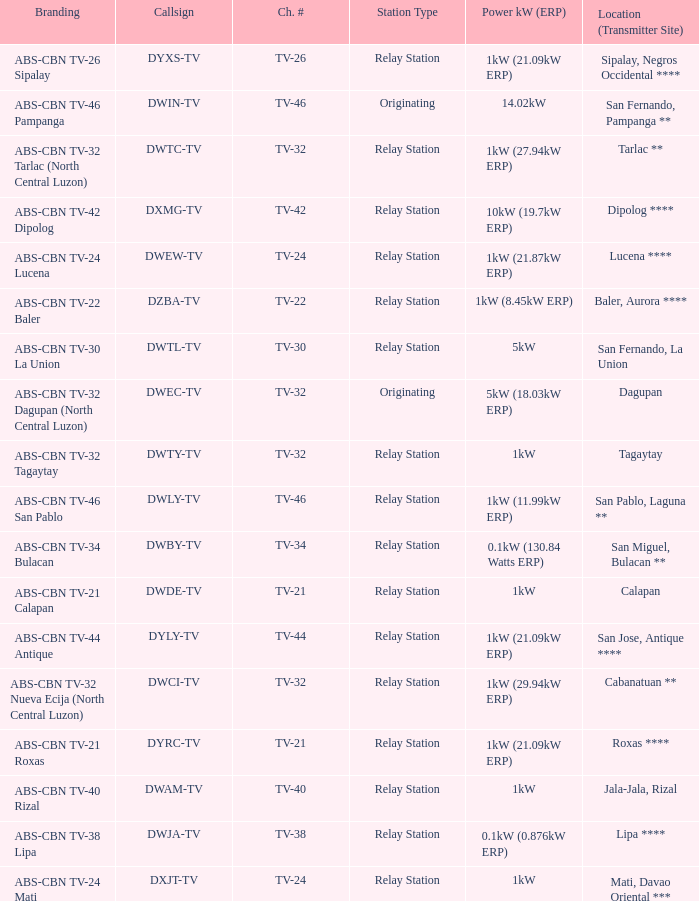How many brandings are there where the Power kW (ERP) is 1kW (29.94kW ERP)? 1.0. 